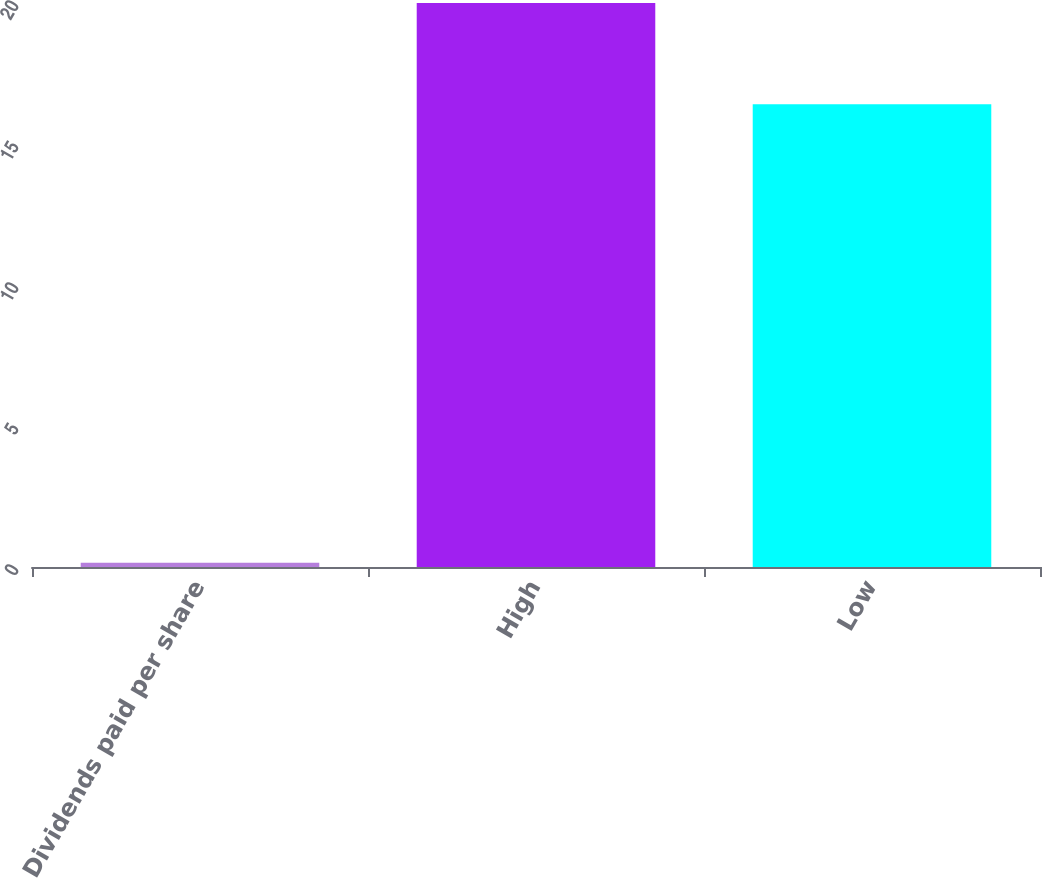Convert chart to OTSL. <chart><loc_0><loc_0><loc_500><loc_500><bar_chart><fcel>Dividends paid per share<fcel>High<fcel>Low<nl><fcel>0.15<fcel>20<fcel>16.41<nl></chart> 